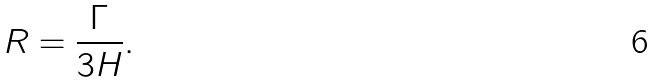<formula> <loc_0><loc_0><loc_500><loc_500>R = \frac { \Gamma } { 3 H } .</formula> 